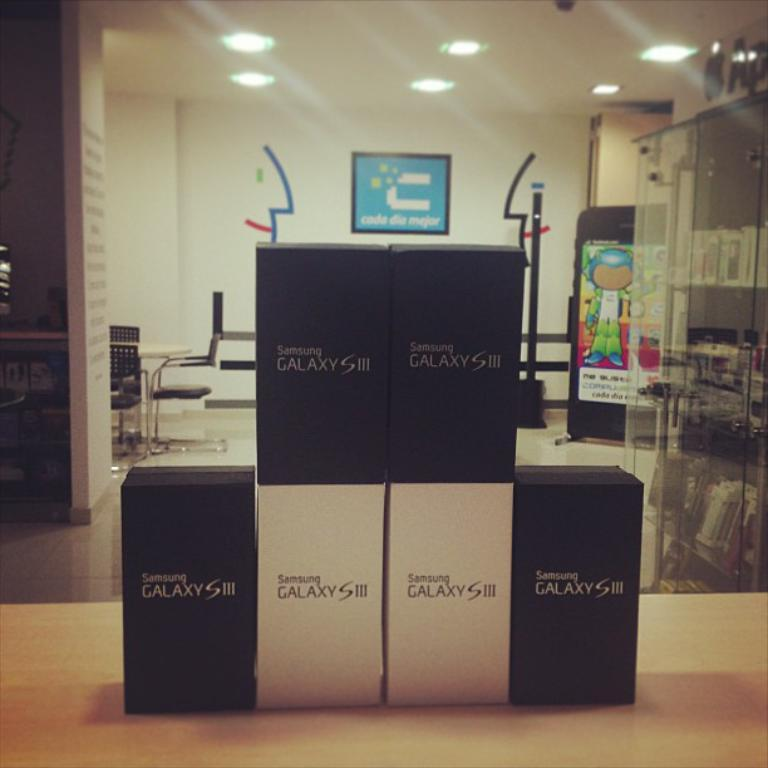<image>
Present a compact description of the photo's key features. 6 black and white glaxy s111 samsung phone boxes 